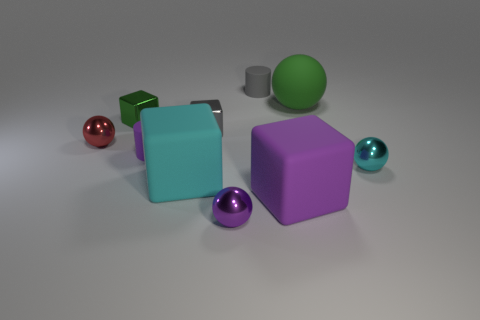What material is the green block?
Your response must be concise. Metal. What number of tiny rubber cylinders are behind the gray matte cylinder?
Keep it short and to the point. 0. What material is the thing that is in front of the small cyan metal thing and left of the purple metal ball?
Give a very brief answer. Rubber. How many tiny objects are red metal balls or green blocks?
Provide a short and direct response. 2. What size is the gray cube?
Your answer should be compact. Small. What is the shape of the purple metallic object?
Your response must be concise. Sphere. Are there fewer green metallic objects that are in front of the purple shiny ball than gray objects?
Give a very brief answer. Yes. Do the tiny metallic object that is behind the tiny gray cube and the matte ball have the same color?
Give a very brief answer. Yes. How many matte objects are green objects or red balls?
Your answer should be very brief. 1. There is a large sphere that is the same material as the purple cylinder; what is its color?
Make the answer very short. Green. 